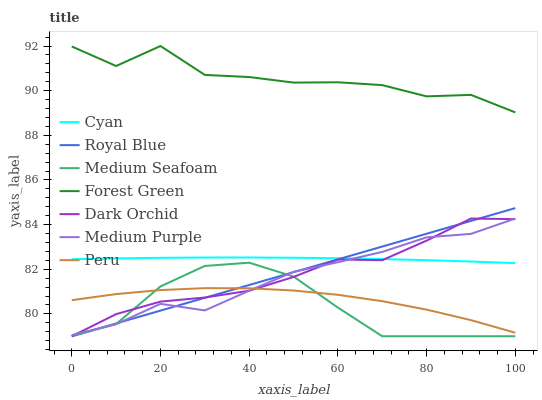Does Medium Seafoam have the minimum area under the curve?
Answer yes or no. Yes. Does Forest Green have the maximum area under the curve?
Answer yes or no. Yes. Does Medium Purple have the minimum area under the curve?
Answer yes or no. No. Does Medium Purple have the maximum area under the curve?
Answer yes or no. No. Is Royal Blue the smoothest?
Answer yes or no. Yes. Is Forest Green the roughest?
Answer yes or no. Yes. Is Medium Purple the smoothest?
Answer yes or no. No. Is Medium Purple the roughest?
Answer yes or no. No. Does Dark Orchid have the lowest value?
Answer yes or no. Yes. Does Medium Purple have the lowest value?
Answer yes or no. No. Does Forest Green have the highest value?
Answer yes or no. Yes. Does Medium Purple have the highest value?
Answer yes or no. No. Is Dark Orchid less than Forest Green?
Answer yes or no. Yes. Is Forest Green greater than Medium Purple?
Answer yes or no. Yes. Does Medium Purple intersect Dark Orchid?
Answer yes or no. Yes. Is Medium Purple less than Dark Orchid?
Answer yes or no. No. Is Medium Purple greater than Dark Orchid?
Answer yes or no. No. Does Dark Orchid intersect Forest Green?
Answer yes or no. No. 